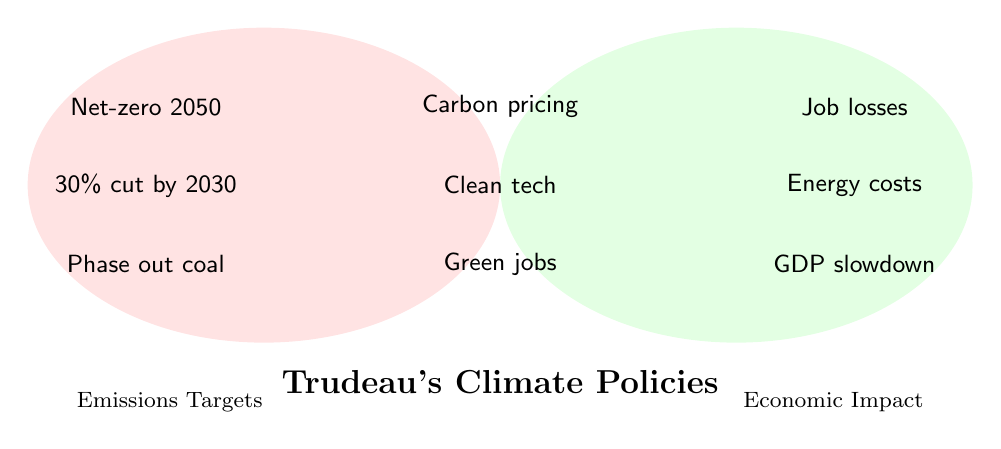What is the title of the Venn Diagram? The title is typically located prominently and explains the main topic.
Answer: Trudeau's Climate Policies Which policies only impact emissions targets? Identify policies in the left circle that do not overlap with the right circle.
Answer: Net-zero 2050, 30% cut by 2030, Phase out coal Which economic impacts are not linked to emissions targets? Identify elements in the right circle that do not overlap with the left circle.
Answer: Job losses, Energy costs, GDP slowdown What policy relates to both emissions targets and economic impact in terms of market mechanisms? Check the overlapping area for policies related to market mechanisms.
Answer: Carbon pricing How many policies impact both emissions targets and economic aspects? Count the number of policies in the overlapping section.
Answer: 3 Compare the number of policies focused solely on emissions targets to those focused solely on economic impact. Identify policies in each non-overlapping section and compare the counts.
Answer: Emissions: 3, Economic: 3 Which emissions target policy might result in renewable energy jobs? Identify policies in the left circle related to emissions targets and check if they mention renewable energy jobs.
Answer: Stricter vehicle emission standards What are the potential economic concerns associated with stricter vehicle emission standards? Look for associated economic impacts in the diagram.
Answer: GDP slowdown Which areas indicate the potential for clean technology investments? Find areas where clean technology investments are mentioned.
Answer: Both (overlapping section) Identify one emissions target and its corresponding economic impact based on the figure. Pair one emissions target with an economic impact mentioned in the diagram.
Answer: Net-zero 2050 with Job losses 